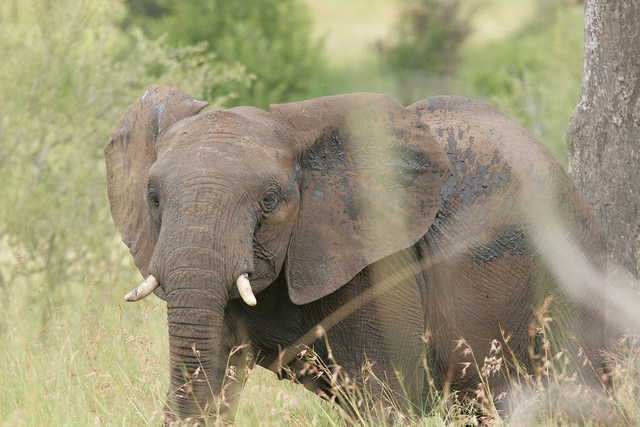Describe the objects in this image and their specific colors. I can see a elephant in tan, gray, and darkgray tones in this image. 